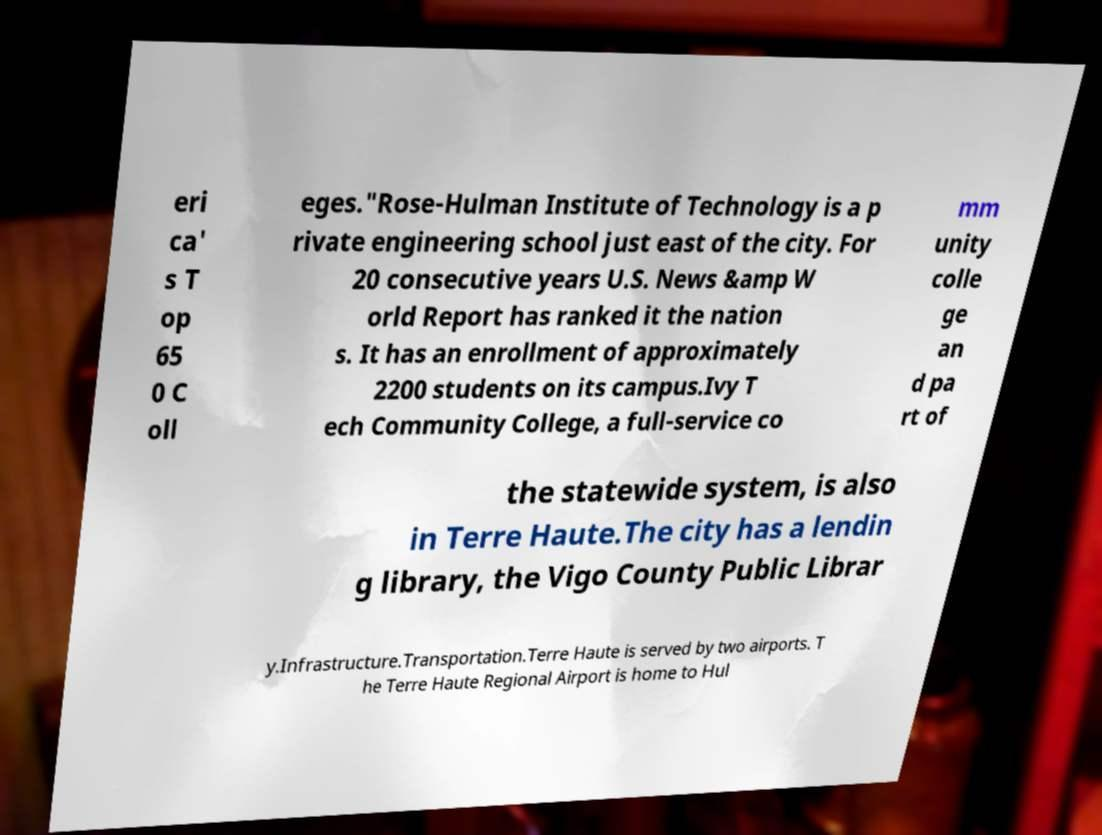For documentation purposes, I need the text within this image transcribed. Could you provide that? eri ca' s T op 65 0 C oll eges."Rose-Hulman Institute of Technology is a p rivate engineering school just east of the city. For 20 consecutive years U.S. News &amp W orld Report has ranked it the nation s. It has an enrollment of approximately 2200 students on its campus.Ivy T ech Community College, a full-service co mm unity colle ge an d pa rt of the statewide system, is also in Terre Haute.The city has a lendin g library, the Vigo County Public Librar y.Infrastructure.Transportation.Terre Haute is served by two airports. T he Terre Haute Regional Airport is home to Hul 